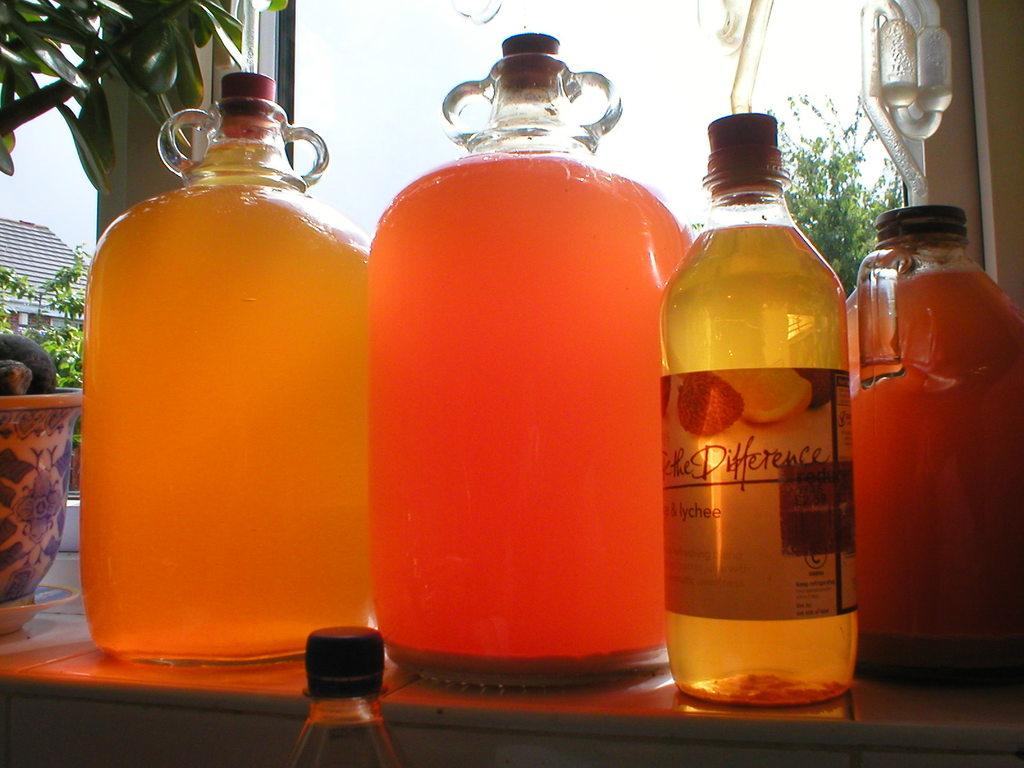Provide a one-sentence caption for the provided image. Four containers on a table one of which labeled DIfference. 